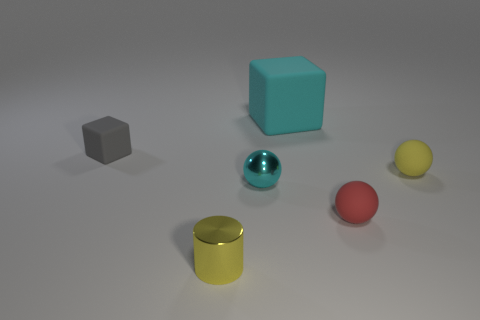What is the material of the tiny gray thing?
Your answer should be compact. Rubber. How many other things are made of the same material as the tiny gray object?
Your answer should be compact. 3. What size is the object that is both to the left of the tiny cyan object and in front of the gray object?
Ensure brevity in your answer.  Small. The yellow object left of the small rubber sphere that is behind the red sphere is what shape?
Offer a very short reply. Cylinder. Are there any other things that are the same shape as the tiny gray rubber thing?
Provide a short and direct response. Yes. Are there the same number of cyan shiny objects in front of the tiny yellow metallic cylinder and red matte balls?
Offer a terse response. No. Is the color of the tiny cylinder the same as the cube that is on the right side of the tiny yellow metal cylinder?
Your answer should be compact. No. What color is the tiny thing that is right of the tiny cube and on the left side of the cyan ball?
Ensure brevity in your answer.  Yellow. What number of tiny yellow balls are to the right of the tiny metal thing to the right of the small shiny cylinder?
Your answer should be compact. 1. Is there another gray matte object of the same shape as the tiny gray rubber object?
Offer a very short reply. No. 